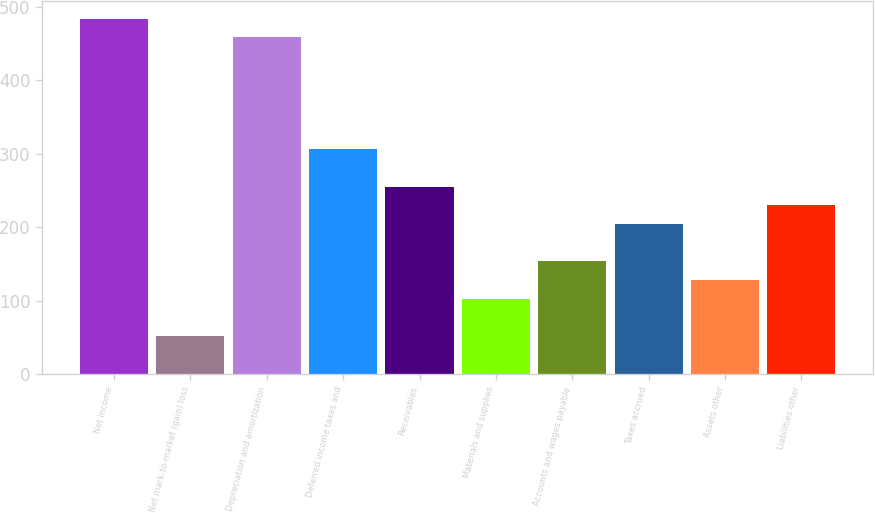Convert chart to OTSL. <chart><loc_0><loc_0><loc_500><loc_500><bar_chart><fcel>Net income<fcel>Net mark-to-market (gain) loss<fcel>Depreciation and amortization<fcel>Deferred income taxes and<fcel>Receivables<fcel>Materials and supplies<fcel>Accounts and wages payable<fcel>Taxes accrued<fcel>Assets other<fcel>Liabilities other<nl><fcel>483.6<fcel>51.8<fcel>458.2<fcel>305.8<fcel>255<fcel>102.6<fcel>153.4<fcel>204.2<fcel>128<fcel>229.6<nl></chart> 